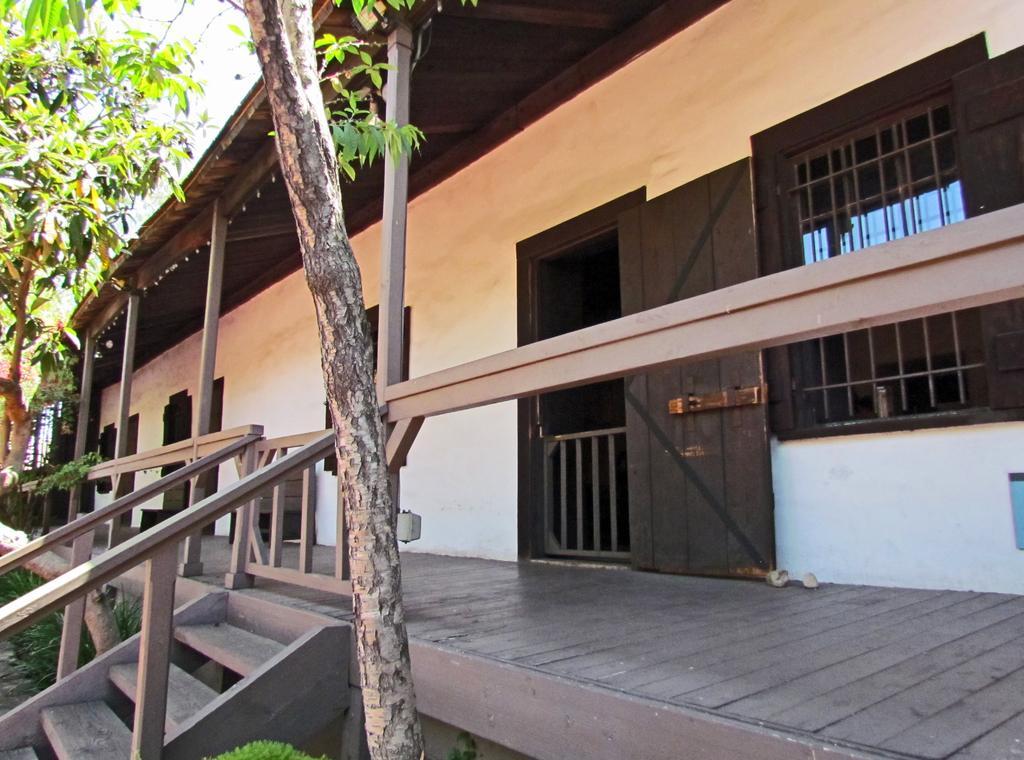Describe this image in one or two sentences. In this image, this looks like a building with the doors and windows. These are the wooden stairs. I can see the trees with branches and leaves. These look like the wooden pillars. 